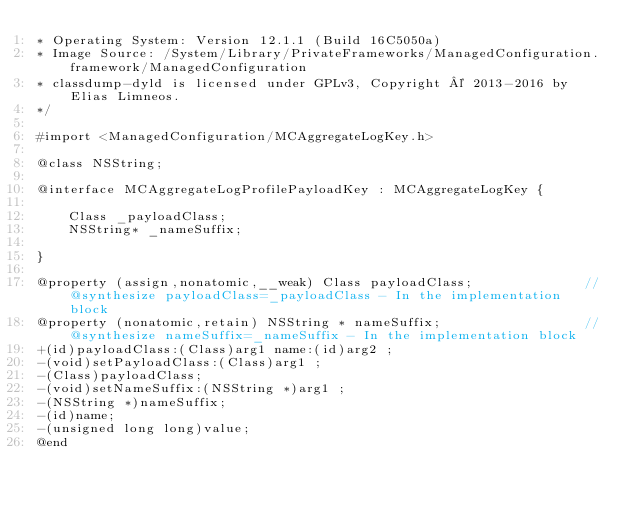<code> <loc_0><loc_0><loc_500><loc_500><_C_>* Operating System: Version 12.1.1 (Build 16C5050a)
* Image Source: /System/Library/PrivateFrameworks/ManagedConfiguration.framework/ManagedConfiguration
* classdump-dyld is licensed under GPLv3, Copyright © 2013-2016 by Elias Limneos.
*/

#import <ManagedConfiguration/MCAggregateLogKey.h>

@class NSString;

@interface MCAggregateLogProfilePayloadKey : MCAggregateLogKey {

	Class _payloadClass;
	NSString* _nameSuffix;

}

@property (assign,nonatomic,__weak) Class payloadClass;              //@synthesize payloadClass=_payloadClass - In the implementation block
@property (nonatomic,retain) NSString * nameSuffix;                  //@synthesize nameSuffix=_nameSuffix - In the implementation block
+(id)payloadClass:(Class)arg1 name:(id)arg2 ;
-(void)setPayloadClass:(Class)arg1 ;
-(Class)payloadClass;
-(void)setNameSuffix:(NSString *)arg1 ;
-(NSString *)nameSuffix;
-(id)name;
-(unsigned long long)value;
@end

</code> 